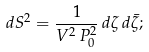Convert formula to latex. <formula><loc_0><loc_0><loc_500><loc_500>d S ^ { 2 } = \frac { 1 } { V ^ { 2 } \, P _ { 0 } ^ { 2 } } \, d \zeta \, d \bar { \zeta } ;</formula> 